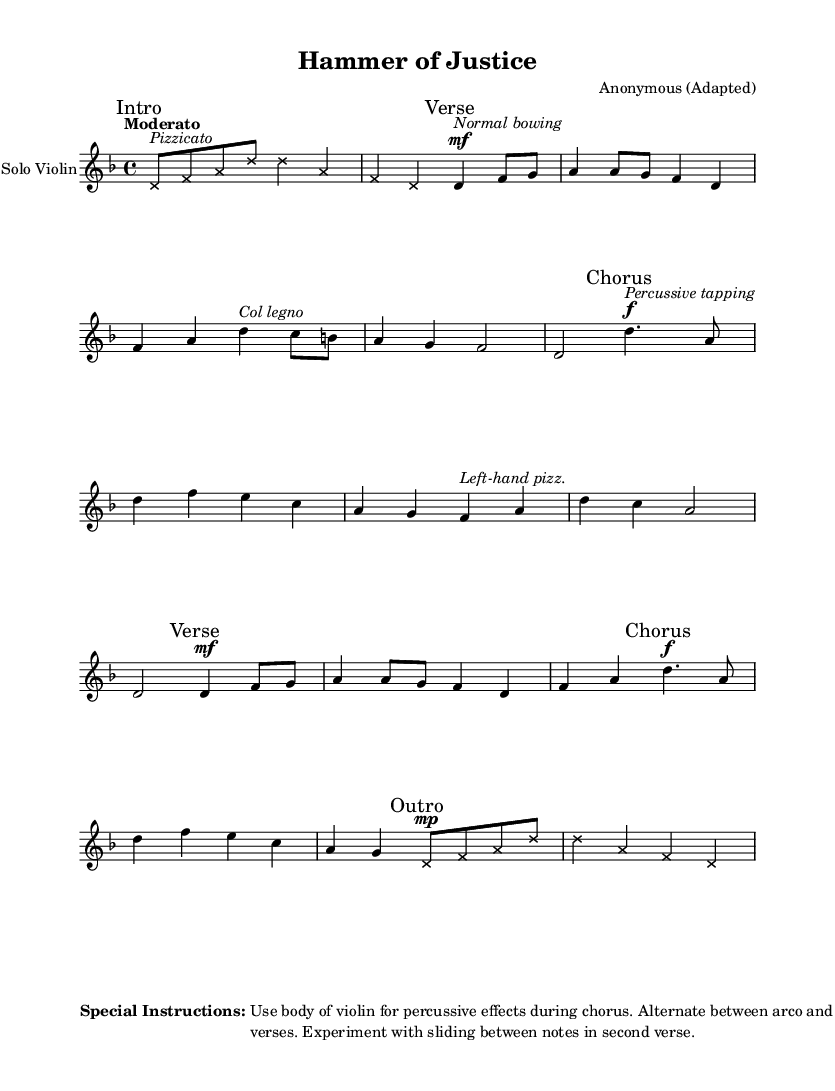What is the key signature of this music? The key signature displays one flat, which indicates that the piece is in D minor.
Answer: D minor What is the time signature of the music? The time signature is indicated as 4/4, which means there are four beats in each measure.
Answer: 4/4 What is the tempo marking for this piece? The tempo marking reads "Moderato," which indicates a moderate speed for performance.
Answer: Moderato What kind of bowing technique is used in the verses? The verses indicate the use of normal bowing, as noted by the instruction written above the first note of the verse section.
Answer: Normal bowing How many measures are there in the chorus section? The chorus section contains four measures, as determined by counting the bars from the beginning to the end of that section.
Answer: Four measures What special instruction is given for percussive effects? The special instruction advises to use the body of the violin for percussive effects, highlighting the incorporation of non-traditional techniques.
Answer: Use body of violin for percussive effects What pizzicato technique is indicated in the chorus? The score specifies "Left-hand pizz." in the chorus section, indicating that this technique should be used during that part of the music.
Answer: Left-hand pizz 